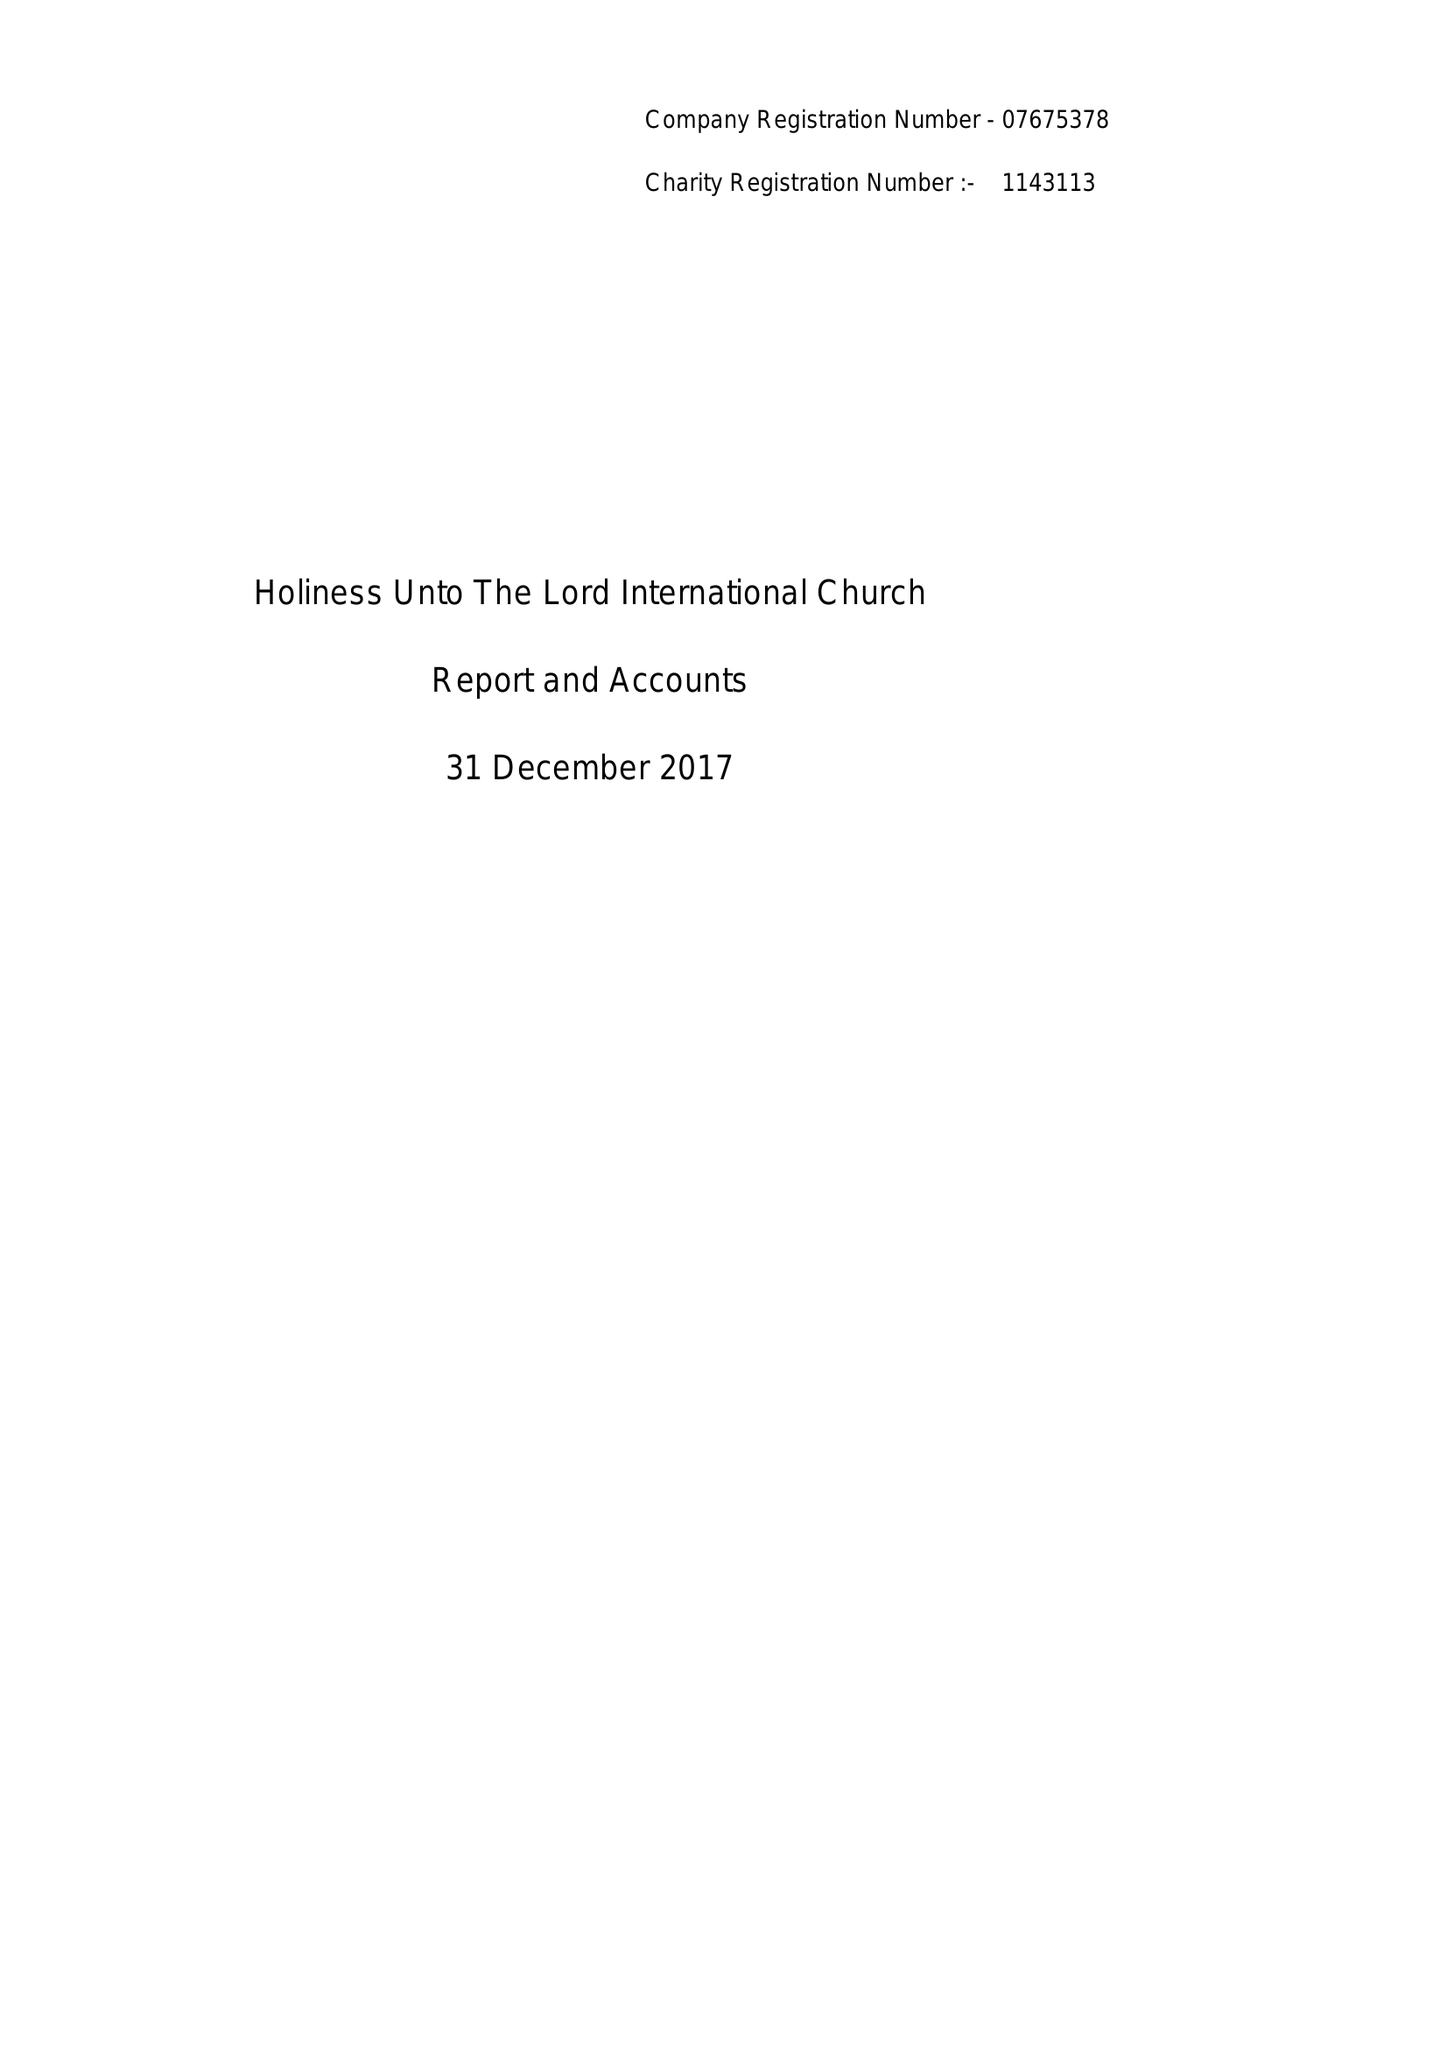What is the value for the address__street_line?
Answer the question using a single word or phrase. 203-205 THE VALE 